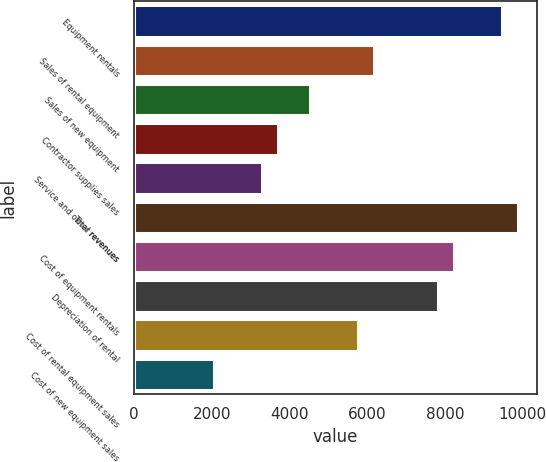Convert chart to OTSL. <chart><loc_0><loc_0><loc_500><loc_500><bar_chart><fcel>Equipment rentals<fcel>Sales of rental equipment<fcel>Sales of new equipment<fcel>Contractor supplies sales<fcel>Service and other revenues<fcel>Total revenues<fcel>Cost of equipment rentals<fcel>Depreciation of rental<fcel>Cost of rental equipment sales<fcel>Cost of new equipment sales<nl><fcel>9463.9<fcel>6173.5<fcel>4528.3<fcel>3705.7<fcel>3294.4<fcel>9875.2<fcel>8230<fcel>7818.7<fcel>5762.2<fcel>2060.5<nl></chart> 